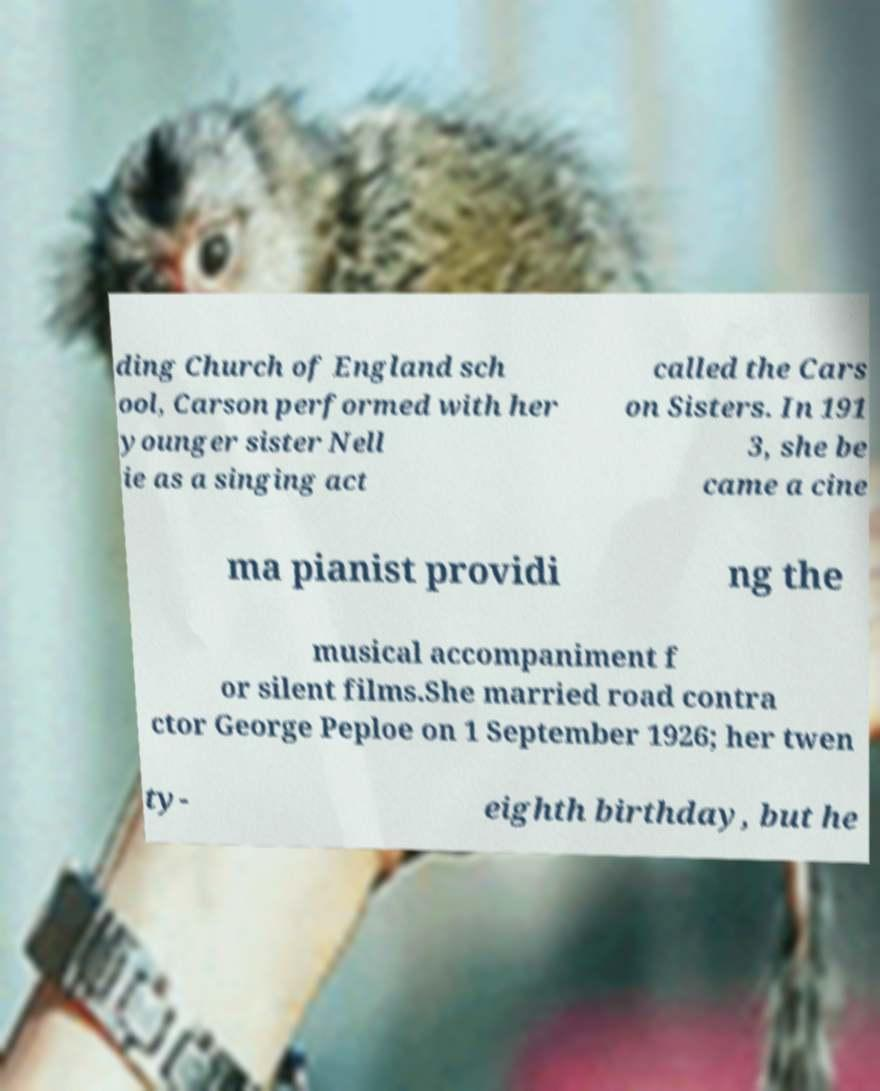Could you assist in decoding the text presented in this image and type it out clearly? ding Church of England sch ool, Carson performed with her younger sister Nell ie as a singing act called the Cars on Sisters. In 191 3, she be came a cine ma pianist providi ng the musical accompaniment f or silent films.She married road contra ctor George Peploe on 1 September 1926; her twen ty- eighth birthday, but he 